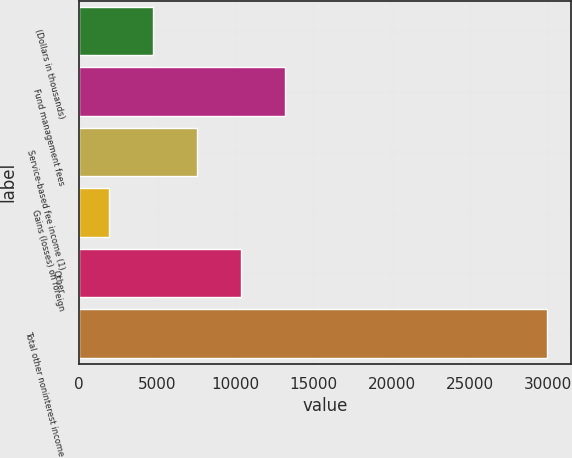<chart> <loc_0><loc_0><loc_500><loc_500><bar_chart><fcel>(Dollars in thousands)<fcel>Fund management fees<fcel>Service-based fee income (1)<fcel>Gains (losses) on foreign<fcel>Other<fcel>Total other noninterest income<nl><fcel>4746.6<fcel>13157.2<fcel>7554<fcel>1945<fcel>10355.6<fcel>29961<nl></chart> 